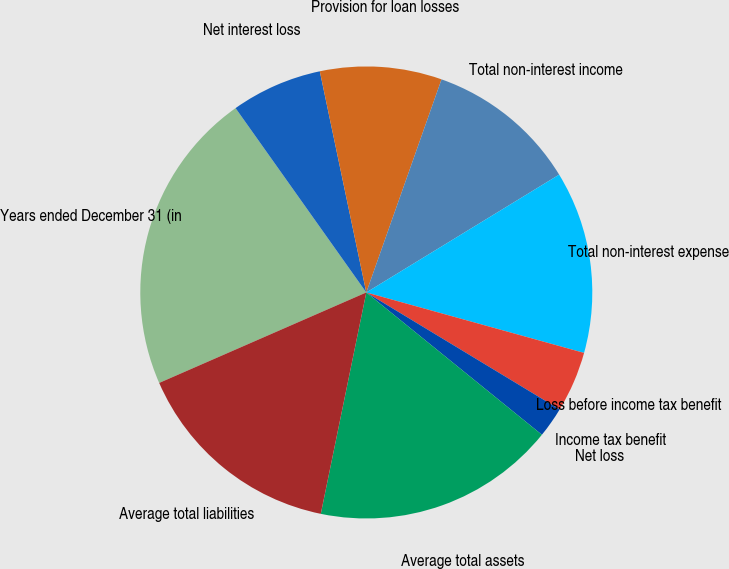Convert chart to OTSL. <chart><loc_0><loc_0><loc_500><loc_500><pie_chart><fcel>Years ended December 31 (in<fcel>Net interest loss<fcel>Provision for loan losses<fcel>Total non-interest income<fcel>Total non-interest expense<fcel>Loss before income tax benefit<fcel>Income tax benefit<fcel>Net loss<fcel>Average total assets<fcel>Average total liabilities<nl><fcel>21.74%<fcel>6.52%<fcel>8.7%<fcel>10.87%<fcel>13.04%<fcel>4.35%<fcel>0.0%<fcel>2.18%<fcel>17.39%<fcel>15.22%<nl></chart> 